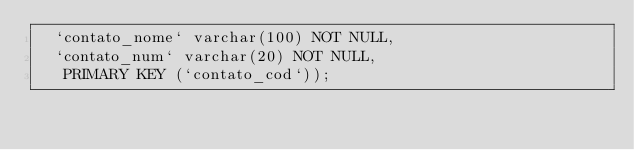Convert code to text. <code><loc_0><loc_0><loc_500><loc_500><_SQL_>  `contato_nome` varchar(100) NOT NULL,
  `contato_num` varchar(20) NOT NULL,
   PRIMARY KEY (`contato_cod`));
</code> 